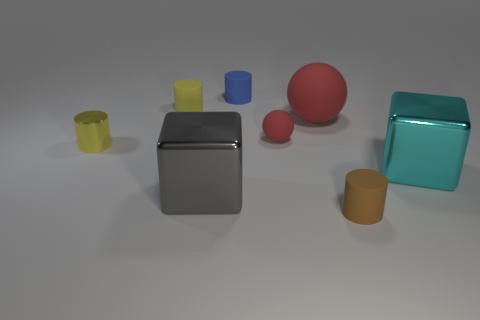Subtract all small brown rubber cylinders. How many cylinders are left? 3 Add 1 yellow rubber cylinders. How many objects exist? 9 Subtract all brown cylinders. How many cylinders are left? 3 Subtract all spheres. How many objects are left? 6 Subtract all purple blocks. How many purple cylinders are left? 0 Subtract all tiny red metallic balls. Subtract all matte spheres. How many objects are left? 6 Add 6 tiny rubber balls. How many tiny rubber balls are left? 7 Add 8 small green cubes. How many small green cubes exist? 8 Subtract 0 purple cylinders. How many objects are left? 8 Subtract 2 cubes. How many cubes are left? 0 